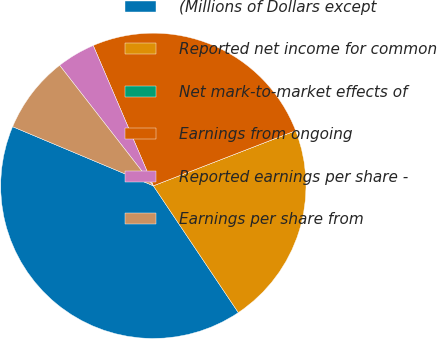Convert chart. <chart><loc_0><loc_0><loc_500><loc_500><pie_chart><fcel>(Millions of Dollars except<fcel>Reported net income for common<fcel>Net mark-to-market effects of<fcel>Earnings from ongoing<fcel>Reported earnings per share -<fcel>Earnings per share from<nl><fcel>40.73%<fcel>21.49%<fcel>0.0%<fcel>25.56%<fcel>4.08%<fcel>8.15%<nl></chart> 